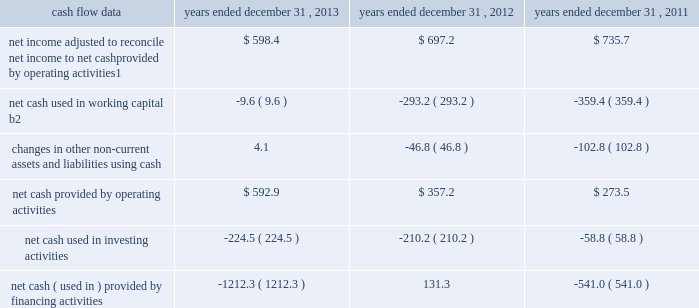Management 2019s discussion and analysis of financial condition and results of operations 2013 ( continued ) ( amounts in millions , except per share amounts ) corporate and other expenses decreased slightly during 2012 by $ 4.7 to $ 137.3 compared to 2011 , primarily due to lower office and general expenses , partially offset by an increase in temporary help to support our information-technology system-upgrade initiatives .
Liquidity and capital resources cash flow overview the tables summarize key financial data relating to our liquidity , capital resources and uses of capital. .
1 reflects net income adjusted primarily for depreciation and amortization of fixed assets and intangible assets , amortization of restricted stock and other non-cash compensation , non-cash loss related to early extinguishment of debt , and deferred income taxes .
2 reflects changes in accounts receivable , expenditures billable to clients , other current assets , accounts payable and accrued liabilities .
Operating activities net cash provided by operating activities during 2013 was $ 592.9 , which was an increase of $ 235.7 as compared to 2012 , primarily as a result of an improvement in working capital usage of $ 283.6 , offset by a decrease in net income .
Due to the seasonality of our business , we typically generate cash from working capital in the second half of a year and use cash from working capital in the first half of a year , with the largest impacts in the first and fourth quarters .
The improvement in working capital in 2013 was impacted by our media businesses and an ongoing focus on working capital management at our agencies .
Net cash provided by operating activities during 2012 was $ 357.2 , which was an increase of $ 83.7 as compared to 2011 , primarily as a result of a decrease in working capital usage of $ 66.2 .
The net working capital usage in 2012 was primarily impacted by our media businesses .
The timing of media buying on behalf of our clients affects our working capital and operating cash flow .
In most of our businesses , our agencies enter into commitments to pay production and media costs on behalf of clients .
To the extent possible we pay production and media charges after we have received funds from our clients .
The amounts involved substantially exceed our revenues , and primarily affect the level of accounts receivable , expenditures billable to clients , accounts payable and accrued liabilities .
Our assets include both cash received and accounts receivable from clients for these pass-through arrangements , while our liabilities include amounts owed on behalf of clients to media and production suppliers .
Our accrued liabilities are also affected by the timing of certain other payments .
For example , while annual cash incentive awards are accrued throughout the year , they are generally paid during the first quarter of the subsequent year .
Investing activities net cash used in investing activities during 2013 primarily relates to payments for capital expenditures and acquisitions .
Capital expenditures of $ 173.0 relate primarily to computer hardware and software and leasehold improvements .
We made payments of $ 61.5 related to acquisitions completed during 2013. .
What is the net change in cash in 2013? 
Computations: ((592.9 + -224.5) + -1212.3)
Answer: -843.9. Management 2019s discussion and analysis of financial condition and results of operations 2013 ( continued ) ( amounts in millions , except per share amounts ) corporate and other expenses decreased slightly during 2012 by $ 4.7 to $ 137.3 compared to 2011 , primarily due to lower office and general expenses , partially offset by an increase in temporary help to support our information-technology system-upgrade initiatives .
Liquidity and capital resources cash flow overview the tables summarize key financial data relating to our liquidity , capital resources and uses of capital. .
1 reflects net income adjusted primarily for depreciation and amortization of fixed assets and intangible assets , amortization of restricted stock and other non-cash compensation , non-cash loss related to early extinguishment of debt , and deferred income taxes .
2 reflects changes in accounts receivable , expenditures billable to clients , other current assets , accounts payable and accrued liabilities .
Operating activities net cash provided by operating activities during 2013 was $ 592.9 , which was an increase of $ 235.7 as compared to 2012 , primarily as a result of an improvement in working capital usage of $ 283.6 , offset by a decrease in net income .
Due to the seasonality of our business , we typically generate cash from working capital in the second half of a year and use cash from working capital in the first half of a year , with the largest impacts in the first and fourth quarters .
The improvement in working capital in 2013 was impacted by our media businesses and an ongoing focus on working capital management at our agencies .
Net cash provided by operating activities during 2012 was $ 357.2 , which was an increase of $ 83.7 as compared to 2011 , primarily as a result of a decrease in working capital usage of $ 66.2 .
The net working capital usage in 2012 was primarily impacted by our media businesses .
The timing of media buying on behalf of our clients affects our working capital and operating cash flow .
In most of our businesses , our agencies enter into commitments to pay production and media costs on behalf of clients .
To the extent possible we pay production and media charges after we have received funds from our clients .
The amounts involved substantially exceed our revenues , and primarily affect the level of accounts receivable , expenditures billable to clients , accounts payable and accrued liabilities .
Our assets include both cash received and accounts receivable from clients for these pass-through arrangements , while our liabilities include amounts owed on behalf of clients to media and production suppliers .
Our accrued liabilities are also affected by the timing of certain other payments .
For example , while annual cash incentive awards are accrued throughout the year , they are generally paid during the first quarter of the subsequent year .
Investing activities net cash used in investing activities during 2013 primarily relates to payments for capital expenditures and acquisitions .
Capital expenditures of $ 173.0 relate primarily to computer hardware and software and leasehold improvements .
We made payments of $ 61.5 related to acquisitions completed during 2013. .
For net cash provided by operating activities in 2013 , how much was lost due to the decrease in net income? 
Rationale: to figure out the decrease in net income , one must take total change without net income and subtract it by the change between the years . this should give you $ 47.9 million .
Computations: (283.6 - 235.7)
Answer: 47.9. Management 2019s discussion and analysis of financial condition and results of operations 2013 ( continued ) ( amounts in millions , except per share amounts ) corporate and other expenses decreased slightly during 2012 by $ 4.7 to $ 137.3 compared to 2011 , primarily due to lower office and general expenses , partially offset by an increase in temporary help to support our information-technology system-upgrade initiatives .
Liquidity and capital resources cash flow overview the tables summarize key financial data relating to our liquidity , capital resources and uses of capital. .
1 reflects net income adjusted primarily for depreciation and amortization of fixed assets and intangible assets , amortization of restricted stock and other non-cash compensation , non-cash loss related to early extinguishment of debt , and deferred income taxes .
2 reflects changes in accounts receivable , expenditures billable to clients , other current assets , accounts payable and accrued liabilities .
Operating activities net cash provided by operating activities during 2013 was $ 592.9 , which was an increase of $ 235.7 as compared to 2012 , primarily as a result of an improvement in working capital usage of $ 283.6 , offset by a decrease in net income .
Due to the seasonality of our business , we typically generate cash from working capital in the second half of a year and use cash from working capital in the first half of a year , with the largest impacts in the first and fourth quarters .
The improvement in working capital in 2013 was impacted by our media businesses and an ongoing focus on working capital management at our agencies .
Net cash provided by operating activities during 2012 was $ 357.2 , which was an increase of $ 83.7 as compared to 2011 , primarily as a result of a decrease in working capital usage of $ 66.2 .
The net working capital usage in 2012 was primarily impacted by our media businesses .
The timing of media buying on behalf of our clients affects our working capital and operating cash flow .
In most of our businesses , our agencies enter into commitments to pay production and media costs on behalf of clients .
To the extent possible we pay production and media charges after we have received funds from our clients .
The amounts involved substantially exceed our revenues , and primarily affect the level of accounts receivable , expenditures billable to clients , accounts payable and accrued liabilities .
Our assets include both cash received and accounts receivable from clients for these pass-through arrangements , while our liabilities include amounts owed on behalf of clients to media and production suppliers .
Our accrued liabilities are also affected by the timing of certain other payments .
For example , while annual cash incentive awards are accrued throughout the year , they are generally paid during the first quarter of the subsequent year .
Investing activities net cash used in investing activities during 2013 primarily relates to payments for capital expenditures and acquisitions .
Capital expenditures of $ 173.0 relate primarily to computer hardware and software and leasehold improvements .
We made payments of $ 61.5 related to acquisitions completed during 2013. .
For net cash provided by operating activities in 2013 , how much was lost due to the decrease in net income? 
Rationale: to figure out the decrease in net income , one must take total change without net income and subtract it by the change between the years . this should give you $ 47.9 million .
Computations: (283.6 - 235.7)
Answer: 47.9. 